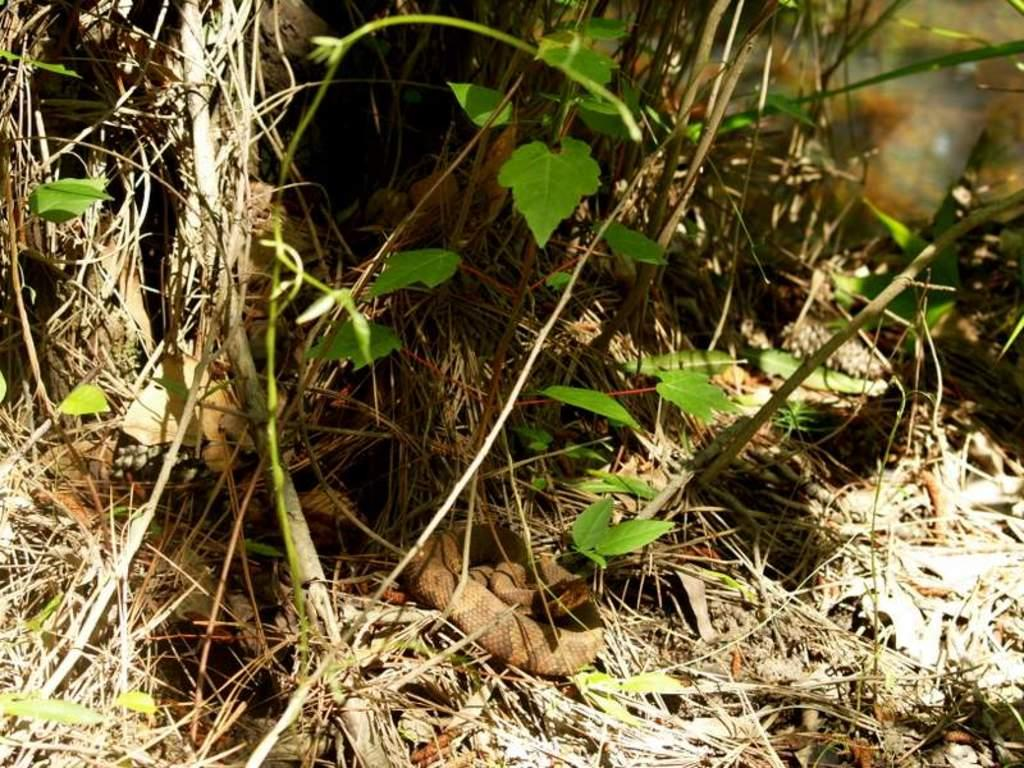What is the main subject in the center of the image? There is a snake in the center of the image. Where is the snake located? The snake is on the ground. What can be seen in the background of the image? There are plants and trees in the background of the image. What color is the crayon being used by the snake in the image? There is no crayon present in the image, and the snake is not using any crayons. 